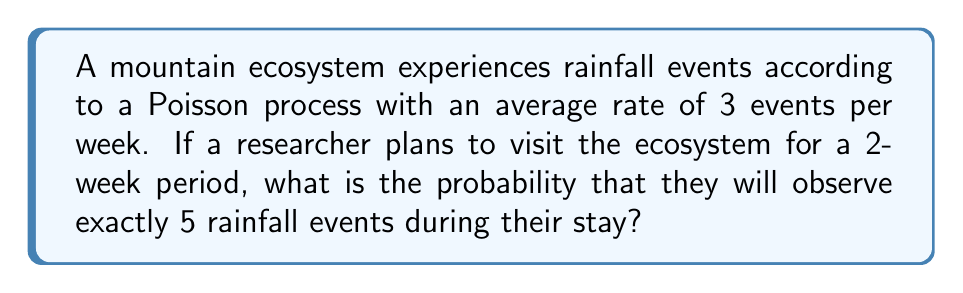Show me your answer to this math problem. To solve this problem, we'll use the Poisson distribution formula:

$$P(X = k) = \frac{e^{-\lambda} \lambda^k}{k!}$$

Where:
$\lambda$ = average number of events in the given time period
$k$ = number of events we're interested in
$e$ = Euler's number (approximately 2.71828)

Step 1: Calculate $\lambda$ for the 2-week period
$\lambda = 3 \text{ events/week} \times 2 \text{ weeks} = 6 \text{ events}$

Step 2: Plug in the values to the Poisson distribution formula
$k = 5$ (we want exactly 5 events)
$\lambda = 6$

$$P(X = 5) = \frac{e^{-6} 6^5}{5!}$$

Step 3: Calculate the numerator
$e^{-6} \approx 0.00247875$
$6^5 = 7776$
$e^{-6} 6^5 \approx 19.27532$

Step 4: Calculate the denominator
$5! = 5 \times 4 \times 3 \times 2 \times 1 = 120$

Step 5: Divide the numerator by the denominator
$$P(X = 5) = \frac{19.27532}{120} \approx 0.16063$$

Therefore, the probability of observing exactly 5 rainfall events during the 2-week stay is approximately 0.16063 or 16.063%.
Answer: 0.16063 